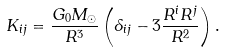<formula> <loc_0><loc_0><loc_500><loc_500>K _ { i j } = \frac { G _ { 0 } M _ { \odot } } { R ^ { 3 } } \left ( \delta _ { i j } - 3 \frac { R ^ { i } R ^ { j } } { R ^ { 2 } } \right ) .</formula> 